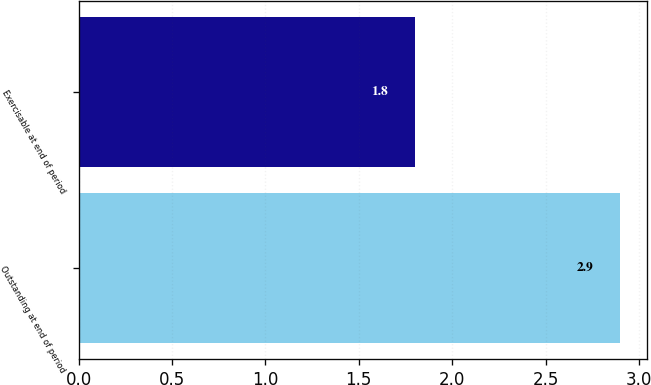<chart> <loc_0><loc_0><loc_500><loc_500><bar_chart><fcel>Outstanding at end of period<fcel>Exercisable at end of period<nl><fcel>2.9<fcel>1.8<nl></chart> 